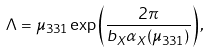Convert formula to latex. <formula><loc_0><loc_0><loc_500><loc_500>\Lambda = \mu _ { 3 3 1 } \exp \left ( { \frac { 2 \pi } { b _ { X } \alpha _ { X } ( \mu _ { 3 3 1 } ) } } \right ) ,</formula> 